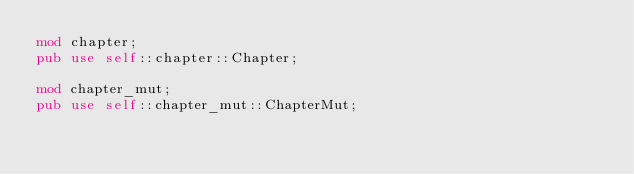<code> <loc_0><loc_0><loc_500><loc_500><_Rust_>mod chapter;
pub use self::chapter::Chapter;

mod chapter_mut;
pub use self::chapter_mut::ChapterMut;
</code> 